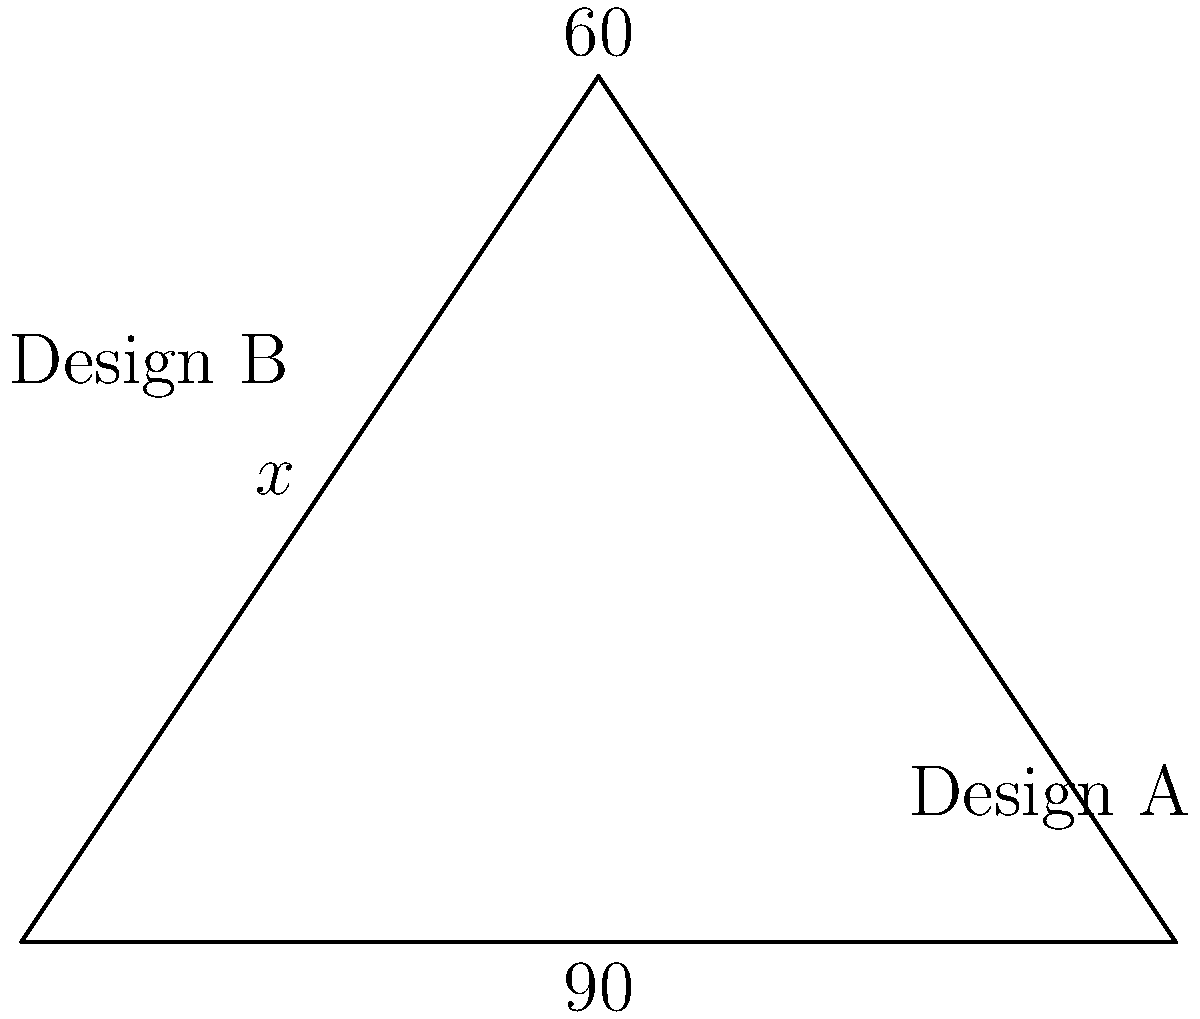Two screen protector designs for a new HTC device intersect at a 90° angle, as shown in the diagram. If one of the designs forms a 60° angle with the base of the triangle, what is the measure of angle $x$ between the two designs? Let's approach this step-by-step:

1) In a triangle, the sum of all interior angles is always 180°.

2) We are given a right angle (90°) at the base of the triangle and another angle of 60°.

3) Let's call the third angle of the triangle $y°$. We can find $y$ using the triangle angle sum theorem:

   $90° + 60° + y° = 180°$
   $150° + y° = 180°$
   $y° = 30°$

4) Now, we need to find angle $x$. Notice that $x$ and $y$ form a straight line with the 60° angle.

5) The sum of angles on a straight line is always 180°. Therefore:

   $x° + 30° + 60° = 180°$

6) Solving for $x$:

   $x° + 90° = 180°$
   $x° = 180° - 90° = 90°$

Therefore, the measure of angle $x$ between the two designs is 90°.
Answer: 90° 